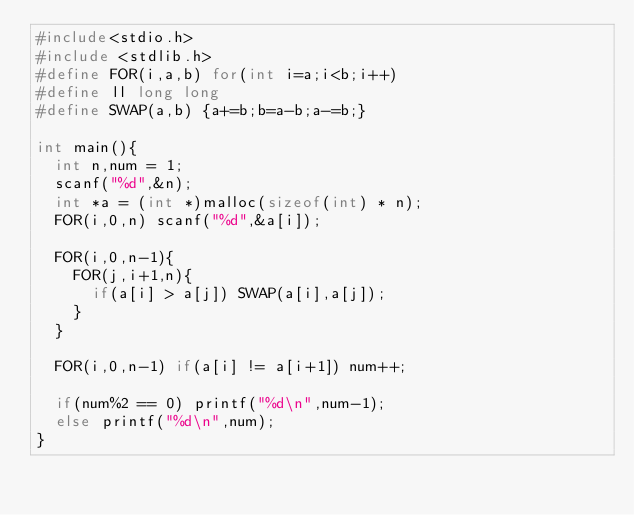Convert code to text. <code><loc_0><loc_0><loc_500><loc_500><_C_>#include<stdio.h>
#include <stdlib.h>
#define FOR(i,a,b) for(int i=a;i<b;i++)
#define ll long long
#define SWAP(a,b) {a+=b;b=a-b;a-=b;}

int main(){
	int n,num = 1;
	scanf("%d",&n);
	int *a = (int *)malloc(sizeof(int) * n);
	FOR(i,0,n) scanf("%d",&a[i]);

	FOR(i,0,n-1){
		FOR(j,i+1,n){
			if(a[i] > a[j]) SWAP(a[i],a[j]);
		}
	}

	FOR(i,0,n-1) if(a[i] != a[i+1]) num++;

	if(num%2 == 0) printf("%d\n",num-1);
	else printf("%d\n",num);
}</code> 